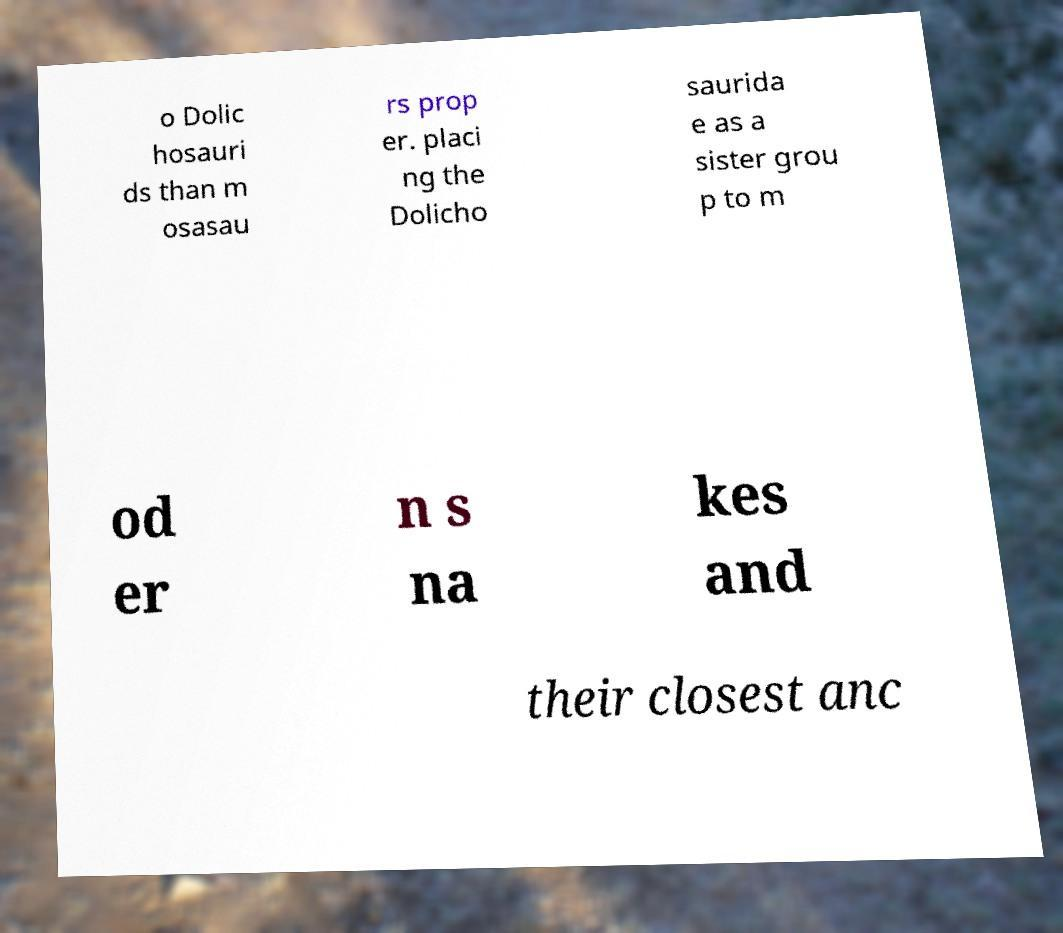Please identify and transcribe the text found in this image. o Dolic hosauri ds than m osasau rs prop er. placi ng the Dolicho saurida e as a sister grou p to m od er n s na kes and their closest anc 